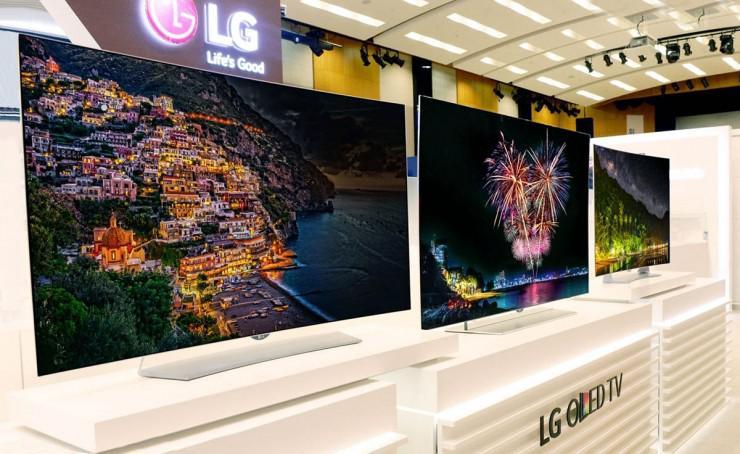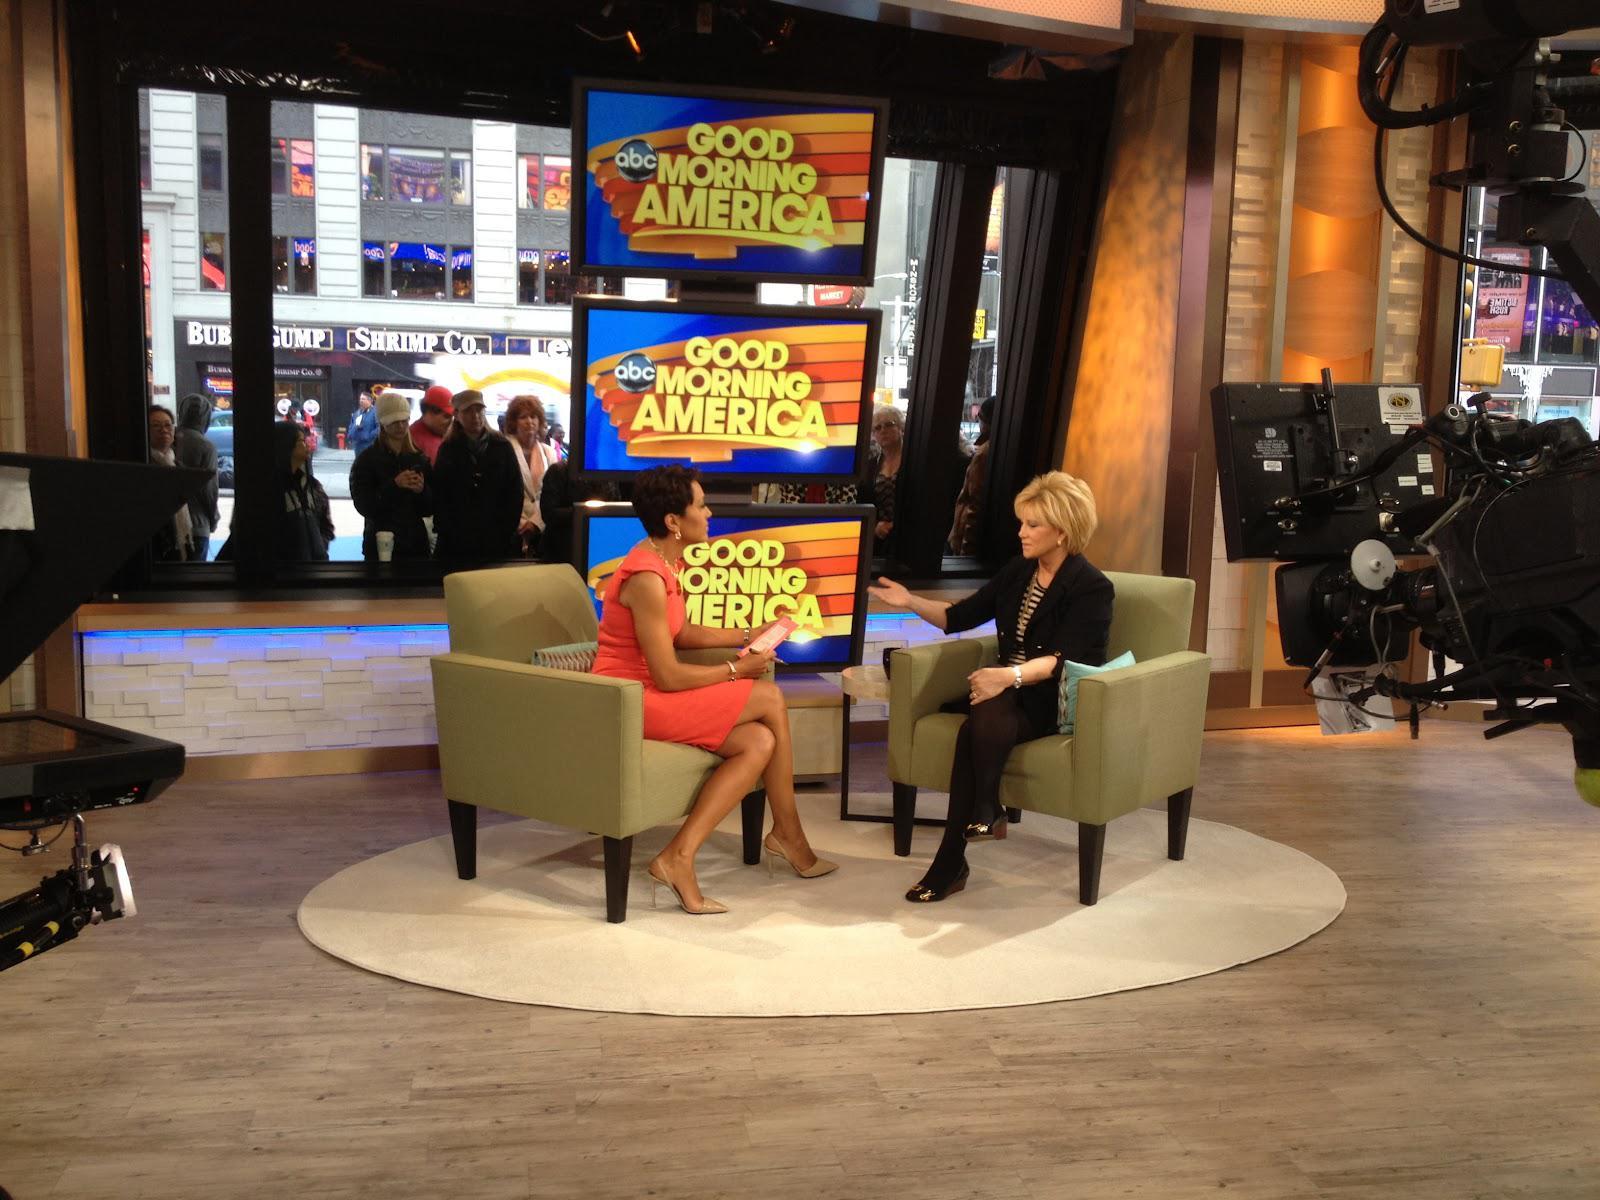The first image is the image on the left, the second image is the image on the right. Analyze the images presented: Is the assertion "An image shows multiple TV screens arranged one atop the other, and includes at least one non-standing person in front of a screen." valid? Answer yes or no. Yes. 